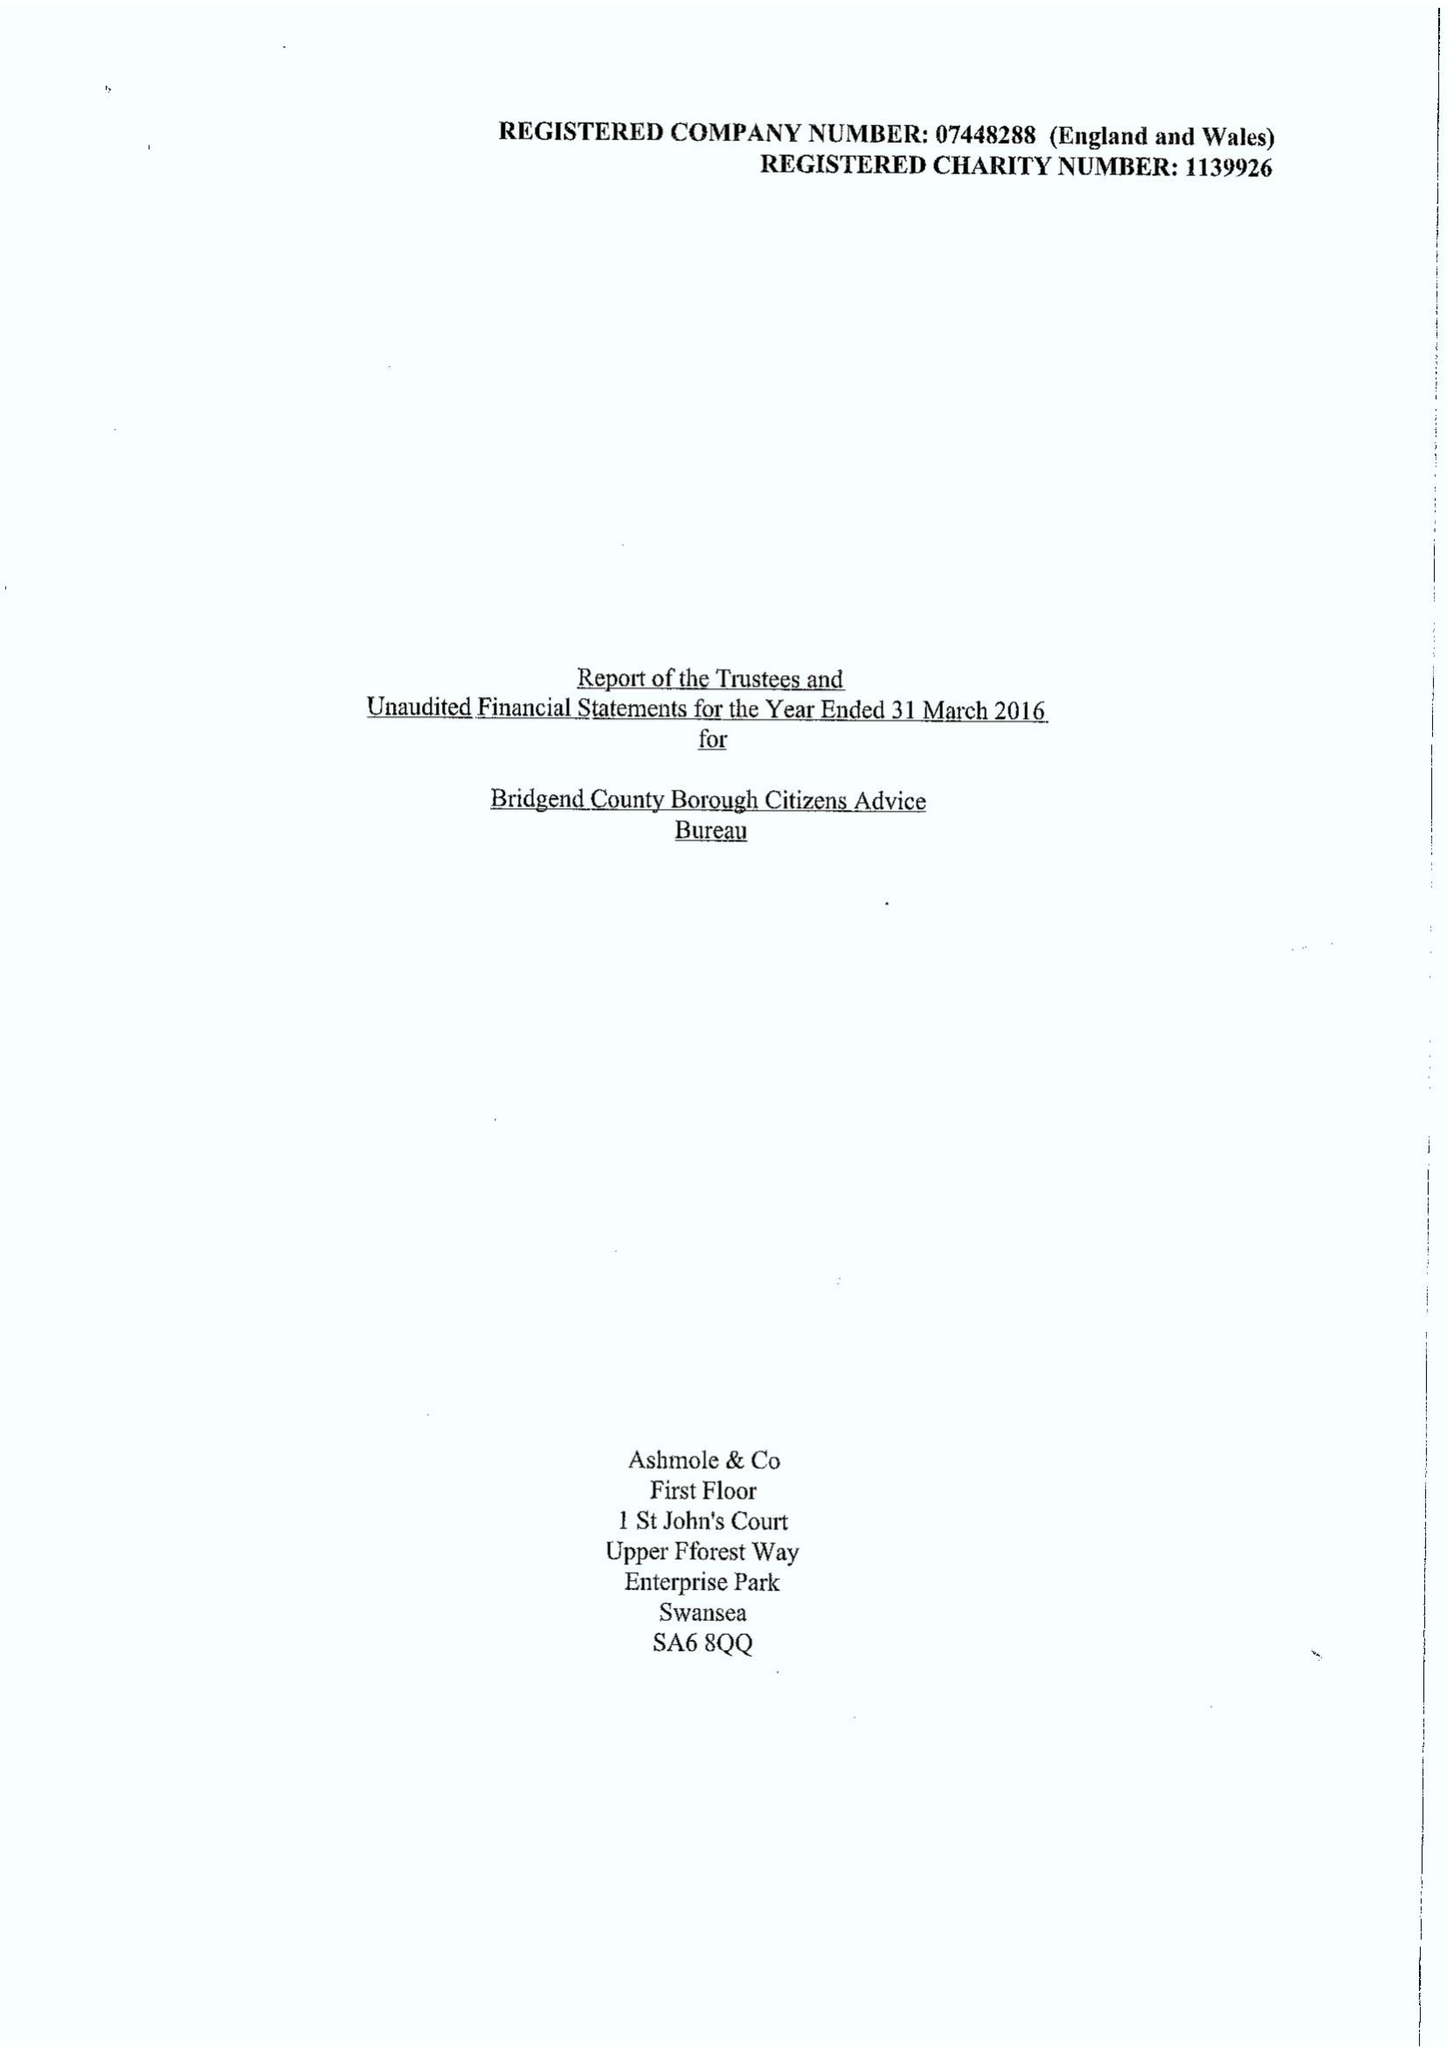What is the value for the address__street_line?
Answer the question using a single word or phrase. 26 DUNRAVEN PLACE 